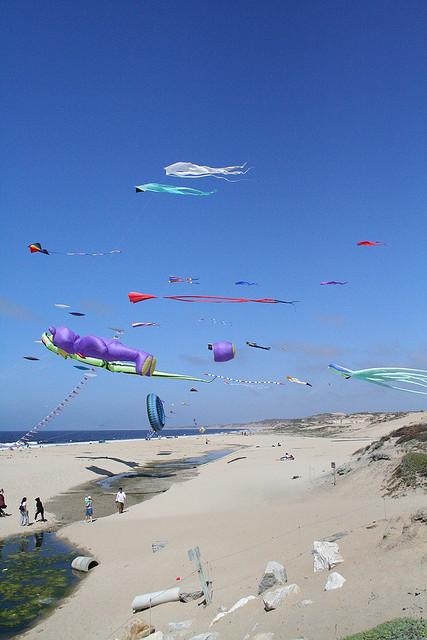What direction is the wind blowing?

Choices:
A) left
B) down
C) right
D) up right 